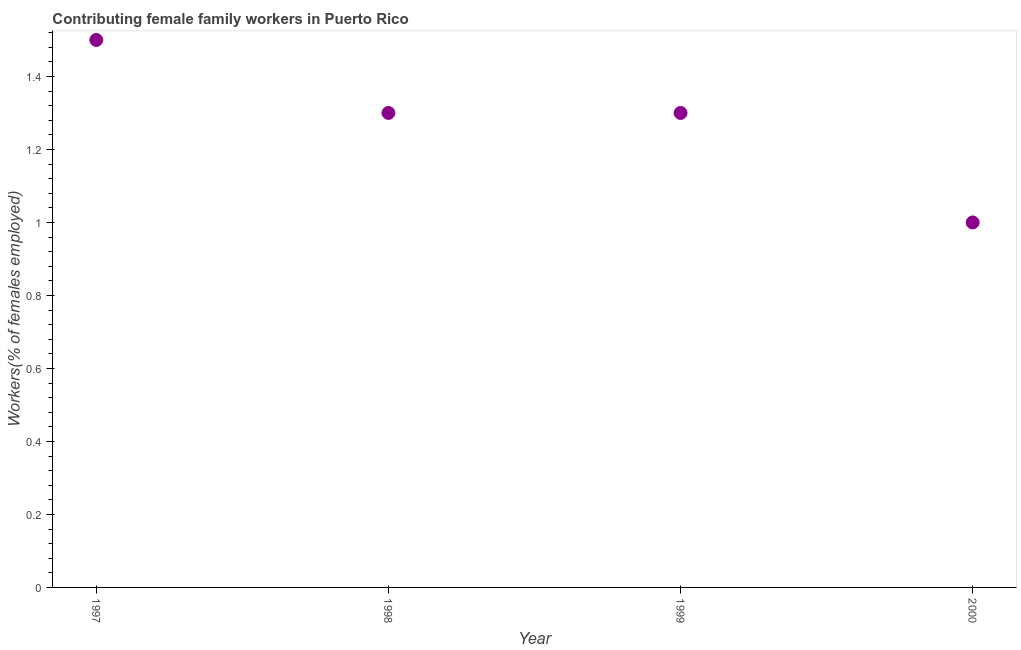In which year was the contributing female family workers minimum?
Provide a short and direct response. 2000. What is the sum of the contributing female family workers?
Ensure brevity in your answer.  5.1. What is the average contributing female family workers per year?
Make the answer very short. 1.27. What is the median contributing female family workers?
Offer a very short reply. 1.3. Do a majority of the years between 1999 and 1997 (inclusive) have contributing female family workers greater than 0.92 %?
Keep it short and to the point. No. What is the ratio of the contributing female family workers in 1997 to that in 1998?
Your answer should be very brief. 1.15. Is the contributing female family workers in 1997 less than that in 1998?
Make the answer very short. No. What is the difference between the highest and the second highest contributing female family workers?
Provide a succinct answer. 0.2. Is the sum of the contributing female family workers in 1999 and 2000 greater than the maximum contributing female family workers across all years?
Your answer should be compact. Yes. In how many years, is the contributing female family workers greater than the average contributing female family workers taken over all years?
Ensure brevity in your answer.  3. Does the contributing female family workers monotonically increase over the years?
Your answer should be very brief. No. How many dotlines are there?
Ensure brevity in your answer.  1. How many years are there in the graph?
Your answer should be very brief. 4. Are the values on the major ticks of Y-axis written in scientific E-notation?
Provide a succinct answer. No. What is the title of the graph?
Make the answer very short. Contributing female family workers in Puerto Rico. What is the label or title of the Y-axis?
Keep it short and to the point. Workers(% of females employed). What is the Workers(% of females employed) in 1997?
Make the answer very short. 1.5. What is the Workers(% of females employed) in 1998?
Provide a short and direct response. 1.3. What is the Workers(% of females employed) in 1999?
Provide a succinct answer. 1.3. What is the difference between the Workers(% of females employed) in 1997 and 1998?
Give a very brief answer. 0.2. What is the difference between the Workers(% of females employed) in 1997 and 1999?
Ensure brevity in your answer.  0.2. What is the difference between the Workers(% of females employed) in 1997 and 2000?
Offer a very short reply. 0.5. What is the difference between the Workers(% of females employed) in 1998 and 1999?
Offer a very short reply. 0. What is the difference between the Workers(% of females employed) in 1998 and 2000?
Your answer should be very brief. 0.3. What is the ratio of the Workers(% of females employed) in 1997 to that in 1998?
Provide a short and direct response. 1.15. What is the ratio of the Workers(% of females employed) in 1997 to that in 1999?
Your answer should be very brief. 1.15. What is the ratio of the Workers(% of females employed) in 1997 to that in 2000?
Give a very brief answer. 1.5. What is the ratio of the Workers(% of females employed) in 1998 to that in 2000?
Your answer should be compact. 1.3. What is the ratio of the Workers(% of females employed) in 1999 to that in 2000?
Offer a terse response. 1.3. 